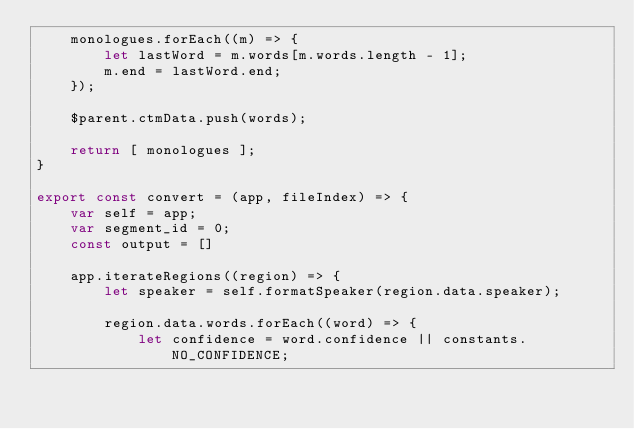<code> <loc_0><loc_0><loc_500><loc_500><_JavaScript_>    monologues.forEach((m) => {
        let lastWord = m.words[m.words.length - 1];
        m.end = lastWord.end;
    });

    $parent.ctmData.push(words);

    return [ monologues ];
}

export const convert = (app, fileIndex) => {
    var self = app;
    var segment_id = 0;
    const output = []

    app.iterateRegions((region) => {
        let speaker = self.formatSpeaker(region.data.speaker);

        region.data.words.forEach((word) => {
            let confidence = word.confidence || constants.NO_CONFIDENCE;</code> 